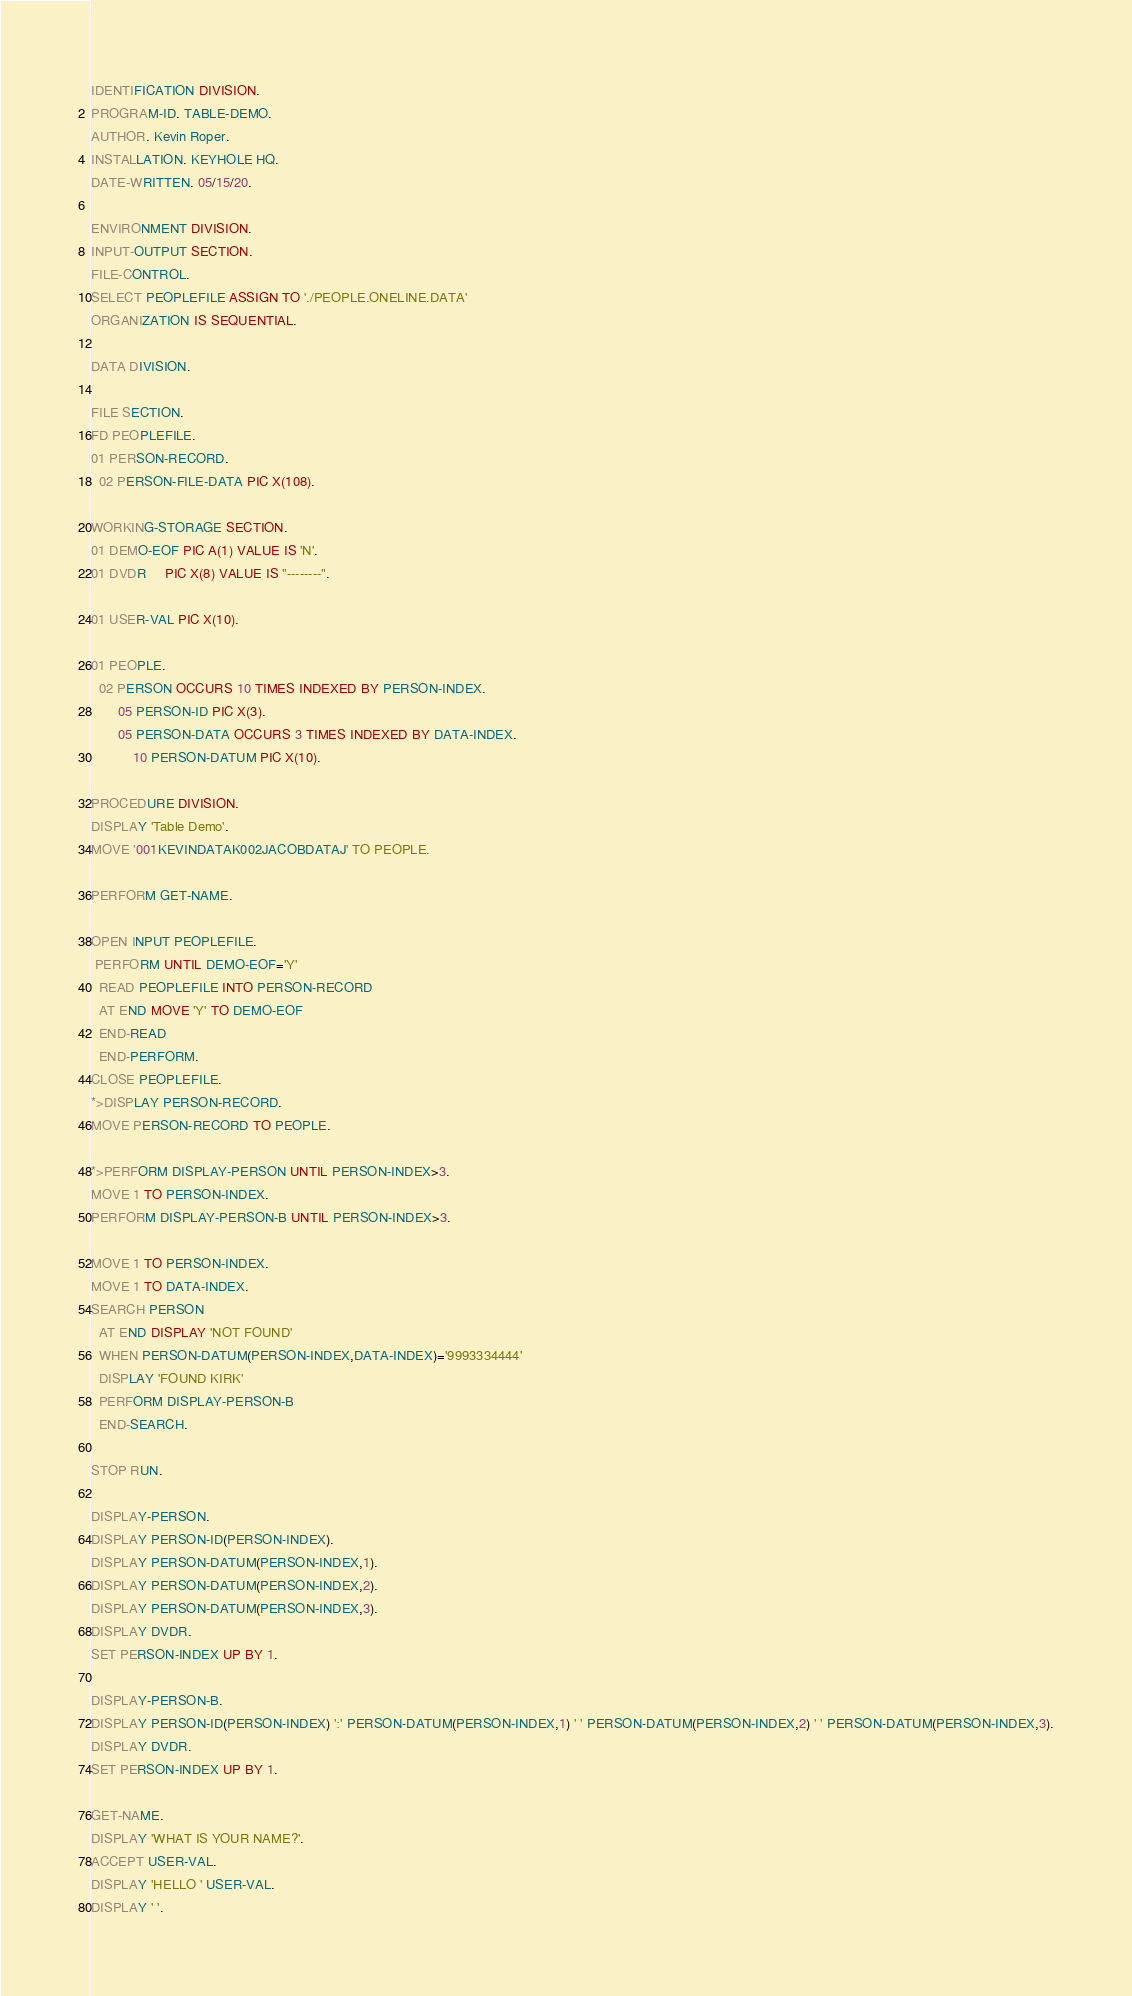Convert code to text. <code><loc_0><loc_0><loc_500><loc_500><_COBOL_>IDENTIFICATION DIVISION.
PROGRAM-ID. TABLE-DEMO.
AUTHOR. Kevin Roper.
INSTALLATION. KEYHOLE HQ.
DATE-WRITTEN. 05/15/20.

ENVIRONMENT DIVISION.
INPUT-OUTPUT SECTION.
FILE-CONTROL.
SELECT PEOPLEFILE ASSIGN TO './PEOPLE.ONELINE.DATA'
ORGANIZATION IS SEQUENTIAL.

DATA DIVISION.

FILE SECTION.
FD PEOPLEFILE.
01 PERSON-RECORD.
  02 PERSON-FILE-DATA PIC X(108).

WORKING-STORAGE SECTION.
01 DEMO-EOF PIC A(1) VALUE IS 'N'.
01 DVDR     PIC X(8) VALUE IS "--------".

01 USER-VAL PIC X(10).

01 PEOPLE.
  02 PERSON OCCURS 10 TIMES INDEXED BY PERSON-INDEX.
       05 PERSON-ID PIC X(3).
       05 PERSON-DATA OCCURS 3 TIMES INDEXED BY DATA-INDEX.
           10 PERSON-DATUM PIC X(10).

PROCEDURE DIVISION.
DISPLAY 'Table Demo'.
MOVE '001KEVINDATAK002JACOBDATAJ' TO PEOPLE.

PERFORM GET-NAME.

OPEN INPUT PEOPLEFILE.
 PERFORM UNTIL DEMO-EOF='Y'
  READ PEOPLEFILE INTO PERSON-RECORD
  AT END MOVE 'Y' TO DEMO-EOF
  END-READ
  END-PERFORM.
CLOSE PEOPLEFILE.
*>DISPLAY PERSON-RECORD.
MOVE PERSON-RECORD TO PEOPLE.

*>PERFORM DISPLAY-PERSON UNTIL PERSON-INDEX>3.
MOVE 1 TO PERSON-INDEX.
PERFORM DISPLAY-PERSON-B UNTIL PERSON-INDEX>3.

MOVE 1 TO PERSON-INDEX.
MOVE 1 TO DATA-INDEX.
SEARCH PERSON
  AT END DISPLAY 'NOT FOUND'
  WHEN PERSON-DATUM(PERSON-INDEX,DATA-INDEX)='9993334444'
  DISPLAY 'FOUND KIRK'
  PERFORM DISPLAY-PERSON-B
  END-SEARCH.

STOP RUN.

DISPLAY-PERSON.
DISPLAY PERSON-ID(PERSON-INDEX).
DISPLAY PERSON-DATUM(PERSON-INDEX,1).
DISPLAY PERSON-DATUM(PERSON-INDEX,2).
DISPLAY PERSON-DATUM(PERSON-INDEX,3).
DISPLAY DVDR.
SET PERSON-INDEX UP BY 1.

DISPLAY-PERSON-B.
DISPLAY PERSON-ID(PERSON-INDEX) ':' PERSON-DATUM(PERSON-INDEX,1) ' ' PERSON-DATUM(PERSON-INDEX,2) ' ' PERSON-DATUM(PERSON-INDEX,3).
DISPLAY DVDR.
SET PERSON-INDEX UP BY 1.

GET-NAME.
DISPLAY 'WHAT IS YOUR NAME?'.
ACCEPT USER-VAL.
DISPLAY 'HELLO ' USER-VAL.
DISPLAY ' '.
</code> 